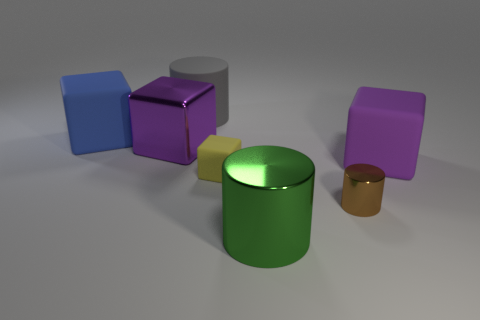How many purple blocks must be subtracted to get 1 purple blocks? 1 Add 1 gray matte cylinders. How many objects exist? 8 Subtract all blocks. How many objects are left? 3 Add 7 blue things. How many blue things are left? 8 Add 6 tiny purple cylinders. How many tiny purple cylinders exist? 6 Subtract 0 red blocks. How many objects are left? 7 Subtract all green spheres. Subtract all gray things. How many objects are left? 6 